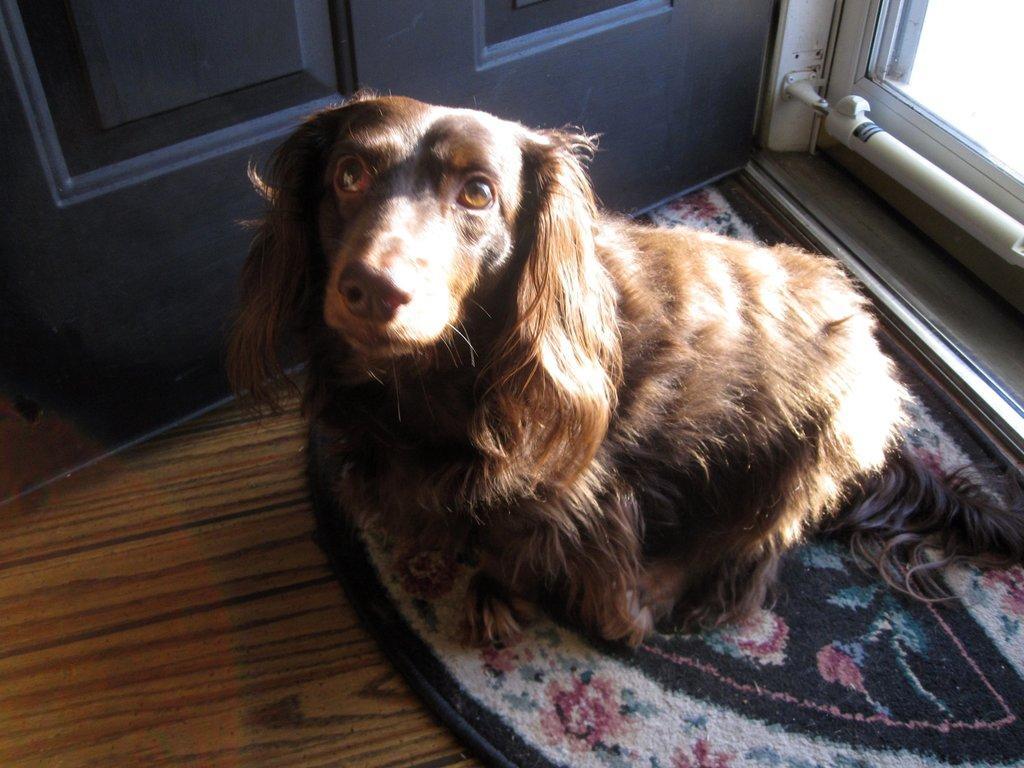Could you give a brief overview of what you see in this image? A dog is sitting on the doormat, it is in brown color, on the left side there is the door. 